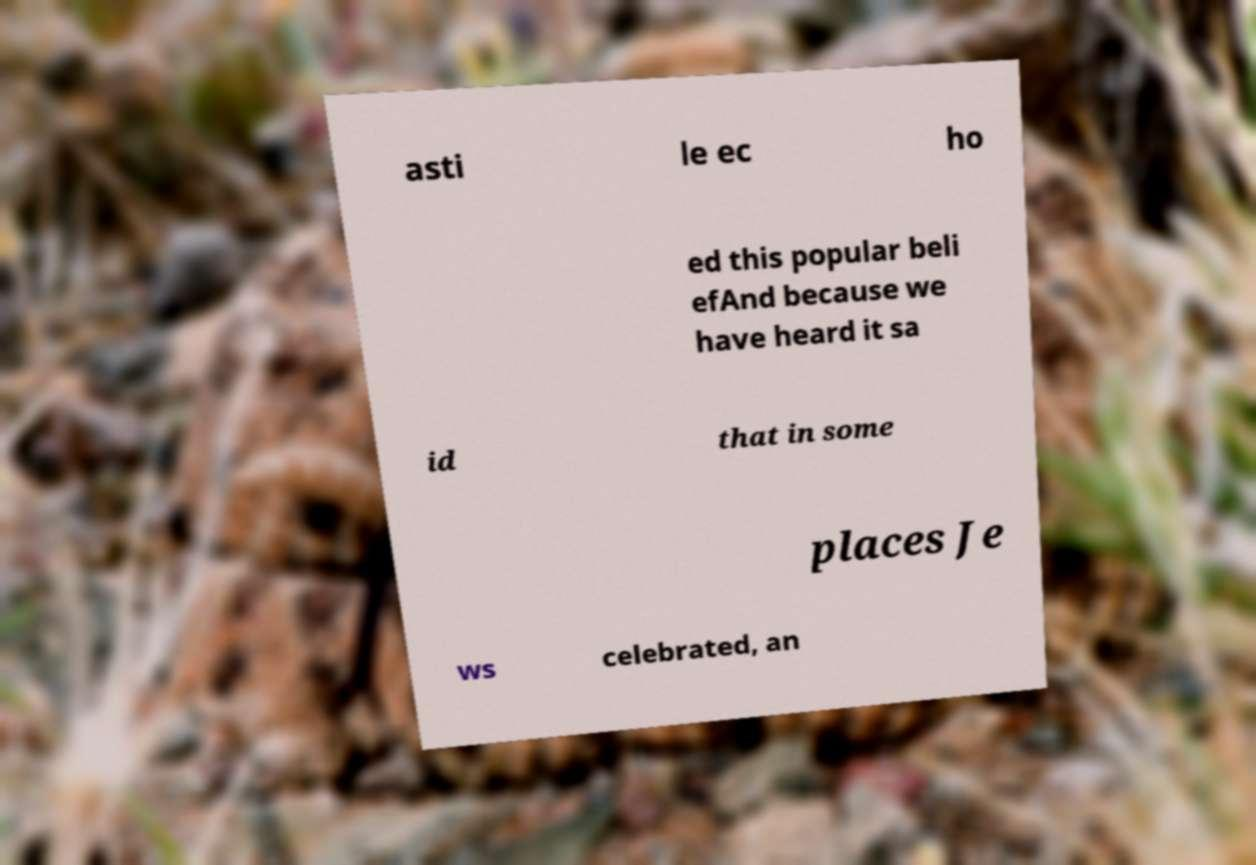Could you assist in decoding the text presented in this image and type it out clearly? asti le ec ho ed this popular beli efAnd because we have heard it sa id that in some places Je ws celebrated, an 